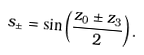<formula> <loc_0><loc_0><loc_500><loc_500>s _ { \pm } = \sin \left ( \frac { z _ { 0 } \pm z _ { 3 } } { 2 } \right ) .</formula> 